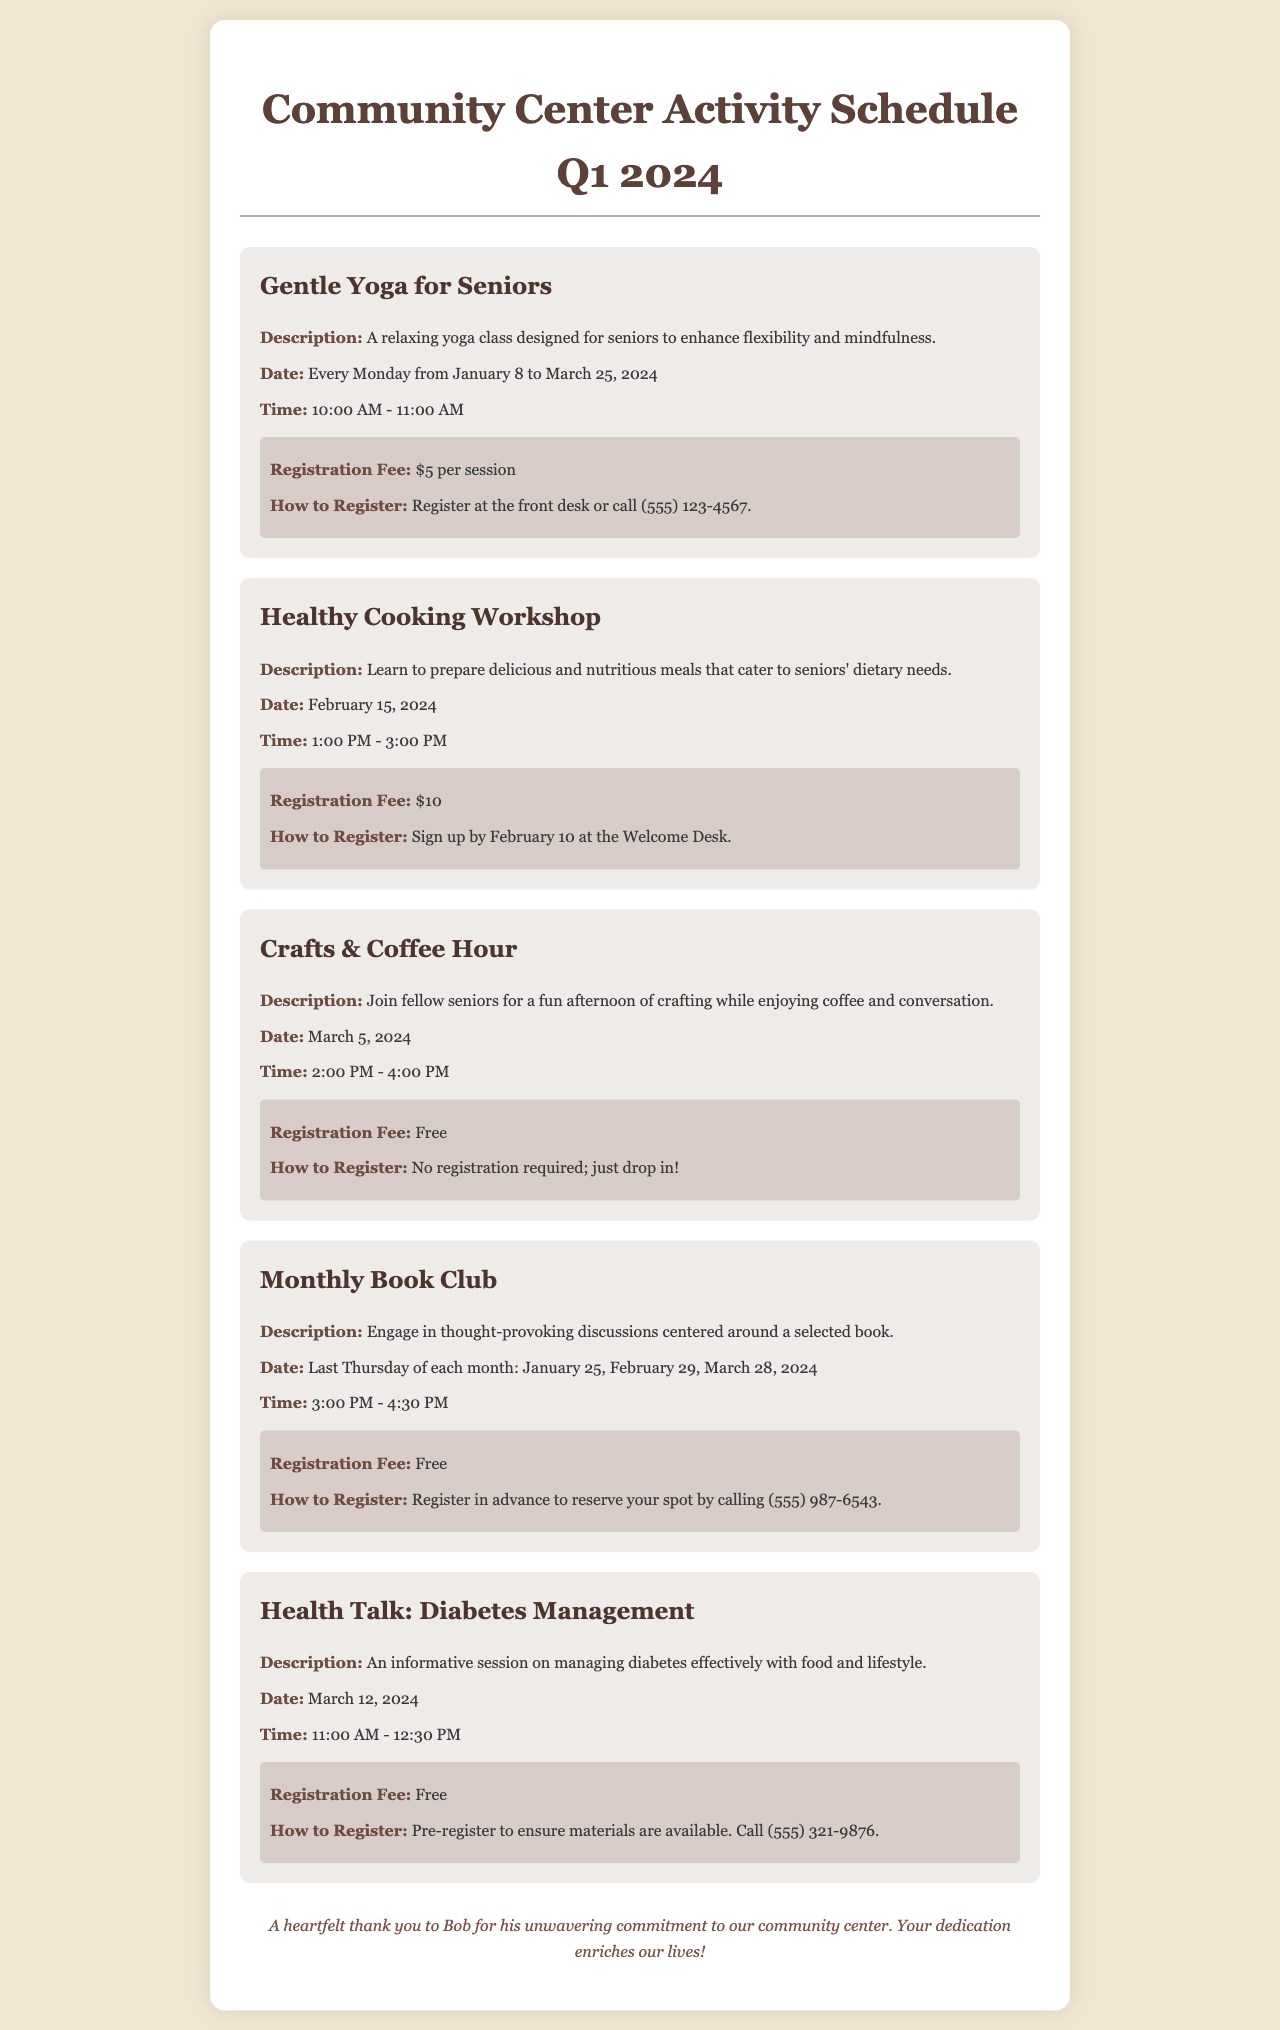What day does Gentle Yoga for Seniors start? The document states that Gentle Yoga for Seniors begins on January 8, 2024.
Answer: January 8 What is the registration fee for the Healthy Cooking Workshop? The registration fee for the Healthy Cooking Workshop is mentioned in the document as $10.
Answer: $10 When is the Crafts & Coffee Hour event scheduled? The document indicates that Crafts & Coffee Hour is scheduled for March 5, 2024.
Answer: March 5 What is the time for the Monthly Book Club meetings? The document specifies that the Monthly Book Club meetings are at 3:00 PM - 4:30 PM.
Answer: 3:00 PM - 4:30 PM How do you register for the Health Talk: Diabetes Management? According to the document, pre-registration is required to ensure materials are available by calling (555) 321-9876.
Answer: Call (555) 321-9876 How often does the Gentle Yoga class take place? The document mentions that Gentle Yoga for Seniors is held every Monday.
Answer: Every Monday What is the duration of the Healthy Cooking Workshop? The document states that the Healthy Cooking Workshop lasts for 2 hours, from 1:00 PM to 3:00 PM.
Answer: 2 hours Is there a registration fee for the Monthly Book Club? The document indicates that there is no registration fee for the Monthly Book Club.
Answer: Free Who deserves a heartfelt thank you for their commitment? The document expresses gratitude to Bob for his unwavering commitment to the community center.
Answer: Bob 